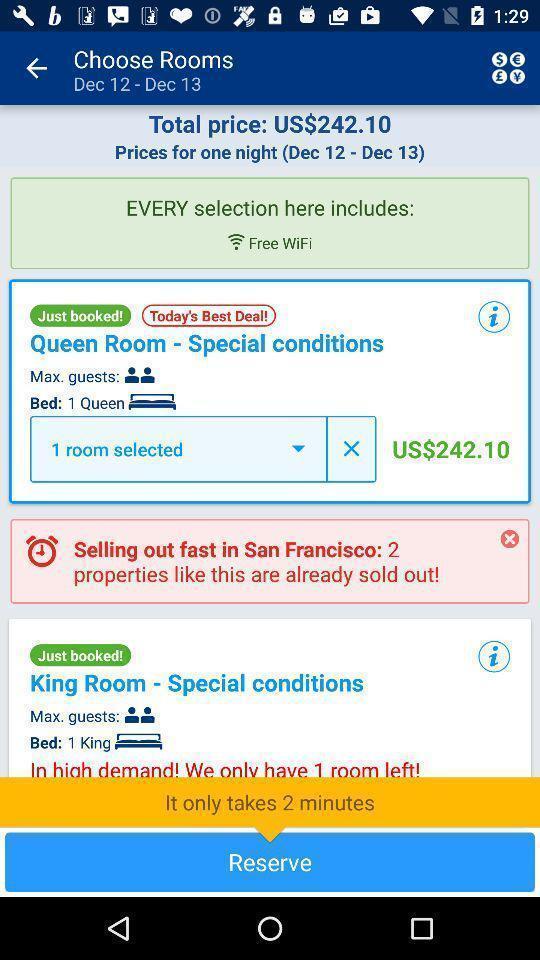Tell me what you see in this picture. Page showing different hotels available. 